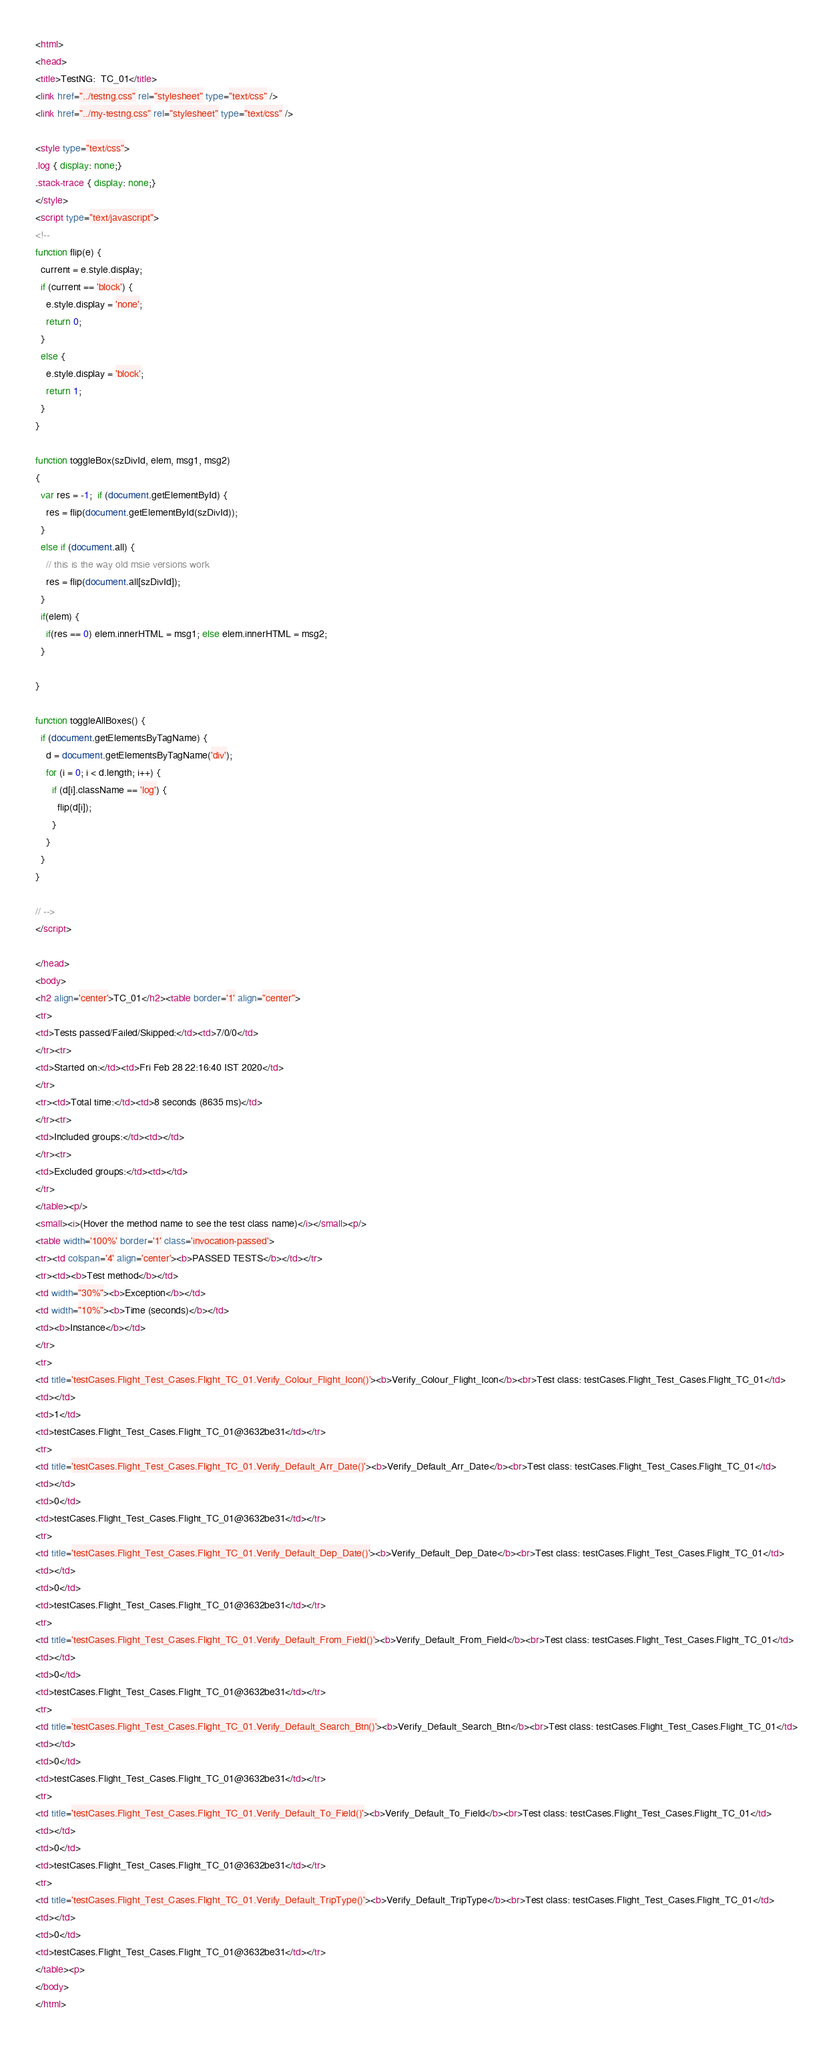Convert code to text. <code><loc_0><loc_0><loc_500><loc_500><_HTML_><html>
<head>
<title>TestNG:  TC_01</title>
<link href="../testng.css" rel="stylesheet" type="text/css" />
<link href="../my-testng.css" rel="stylesheet" type="text/css" />

<style type="text/css">
.log { display: none;} 
.stack-trace { display: none;} 
</style>
<script type="text/javascript">
<!--
function flip(e) {
  current = e.style.display;
  if (current == 'block') {
    e.style.display = 'none';
    return 0;
  }
  else {
    e.style.display = 'block';
    return 1;
  }
}

function toggleBox(szDivId, elem, msg1, msg2)
{
  var res = -1;  if (document.getElementById) {
    res = flip(document.getElementById(szDivId));
  }
  else if (document.all) {
    // this is the way old msie versions work
    res = flip(document.all[szDivId]);
  }
  if(elem) {
    if(res == 0) elem.innerHTML = msg1; else elem.innerHTML = msg2;
  }

}

function toggleAllBoxes() {
  if (document.getElementsByTagName) {
    d = document.getElementsByTagName('div');
    for (i = 0; i < d.length; i++) {
      if (d[i].className == 'log') {
        flip(d[i]);
      }
    }
  }
}

// -->
</script>

</head>
<body>
<h2 align='center'>TC_01</h2><table border='1' align="center">
<tr>
<td>Tests passed/Failed/Skipped:</td><td>7/0/0</td>
</tr><tr>
<td>Started on:</td><td>Fri Feb 28 22:16:40 IST 2020</td>
</tr>
<tr><td>Total time:</td><td>8 seconds (8635 ms)</td>
</tr><tr>
<td>Included groups:</td><td></td>
</tr><tr>
<td>Excluded groups:</td><td></td>
</tr>
</table><p/>
<small><i>(Hover the method name to see the test class name)</i></small><p/>
<table width='100%' border='1' class='invocation-passed'>
<tr><td colspan='4' align='center'><b>PASSED TESTS</b></td></tr>
<tr><td><b>Test method</b></td>
<td width="30%"><b>Exception</b></td>
<td width="10%"><b>Time (seconds)</b></td>
<td><b>Instance</b></td>
</tr>
<tr>
<td title='testCases.Flight_Test_Cases.Flight_TC_01.Verify_Colour_Flight_Icon()'><b>Verify_Colour_Flight_Icon</b><br>Test class: testCases.Flight_Test_Cases.Flight_TC_01</td>
<td></td>
<td>1</td>
<td>testCases.Flight_Test_Cases.Flight_TC_01@3632be31</td></tr>
<tr>
<td title='testCases.Flight_Test_Cases.Flight_TC_01.Verify_Default_Arr_Date()'><b>Verify_Default_Arr_Date</b><br>Test class: testCases.Flight_Test_Cases.Flight_TC_01</td>
<td></td>
<td>0</td>
<td>testCases.Flight_Test_Cases.Flight_TC_01@3632be31</td></tr>
<tr>
<td title='testCases.Flight_Test_Cases.Flight_TC_01.Verify_Default_Dep_Date()'><b>Verify_Default_Dep_Date</b><br>Test class: testCases.Flight_Test_Cases.Flight_TC_01</td>
<td></td>
<td>0</td>
<td>testCases.Flight_Test_Cases.Flight_TC_01@3632be31</td></tr>
<tr>
<td title='testCases.Flight_Test_Cases.Flight_TC_01.Verify_Default_From_Field()'><b>Verify_Default_From_Field</b><br>Test class: testCases.Flight_Test_Cases.Flight_TC_01</td>
<td></td>
<td>0</td>
<td>testCases.Flight_Test_Cases.Flight_TC_01@3632be31</td></tr>
<tr>
<td title='testCases.Flight_Test_Cases.Flight_TC_01.Verify_Default_Search_Btn()'><b>Verify_Default_Search_Btn</b><br>Test class: testCases.Flight_Test_Cases.Flight_TC_01</td>
<td></td>
<td>0</td>
<td>testCases.Flight_Test_Cases.Flight_TC_01@3632be31</td></tr>
<tr>
<td title='testCases.Flight_Test_Cases.Flight_TC_01.Verify_Default_To_Field()'><b>Verify_Default_To_Field</b><br>Test class: testCases.Flight_Test_Cases.Flight_TC_01</td>
<td></td>
<td>0</td>
<td>testCases.Flight_Test_Cases.Flight_TC_01@3632be31</td></tr>
<tr>
<td title='testCases.Flight_Test_Cases.Flight_TC_01.Verify_Default_TripType()'><b>Verify_Default_TripType</b><br>Test class: testCases.Flight_Test_Cases.Flight_TC_01</td>
<td></td>
<td>0</td>
<td>testCases.Flight_Test_Cases.Flight_TC_01@3632be31</td></tr>
</table><p>
</body>
</html></code> 